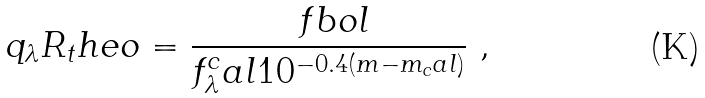<formula> <loc_0><loc_0><loc_500><loc_500>q _ { \lambda } R _ { t } h e o = \frac { \ f b o l } { f _ { \lambda } ^ { c } a l 1 0 ^ { - 0 . 4 ( m - m _ { c } a l ) } } \ ,</formula> 